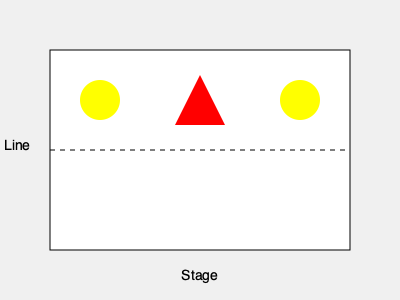Based on the stage lighting plot shown, which type of theatrical lighting setup is depicted, and what effect does it likely create on stage? To identify the theatrical lighting setup and its effect, let's analyze the lighting plot step-by-step:

1. The diagram shows a top-down view of a stage, with the front of the stage at the bottom.

2. There are three main lighting fixtures represented:
   a. Two yellow circles on either side of the stage, near the front
   b. One red triangle in the center, slightly upstage from the other two

3. The yellow circles likely represent:
   - Fresnel or PAR can lights
   - Positioned for front lighting from the sides
   - Often used for key lighting or fill lighting

4. The red triangle in the center likely represents:
   - A spotlight or profile light
   - Positioned for front lighting from the center
   - Often used for highlighting specific areas or actors

5. This arrangement is known as a basic three-point lighting setup, consisting of:
   - Key light (one of the side lights)
   - Fill light (the other side light)
   - Back light or top light (the center light)

6. The effect of this lighting setup:
   - Provides even illumination across the stage
   - Creates depth and dimension by lighting the subject from multiple angles
   - Allows for highlighting of specific areas or actors using the center light
   - Reduces harsh shadows by balancing light from different directions

This setup is versatile and commonly used in theater for general illumination and to create a natural, three-dimensional look on stage.
Answer: Three-point lighting setup; creates even illumination, depth, and allows for specific highlighting. 